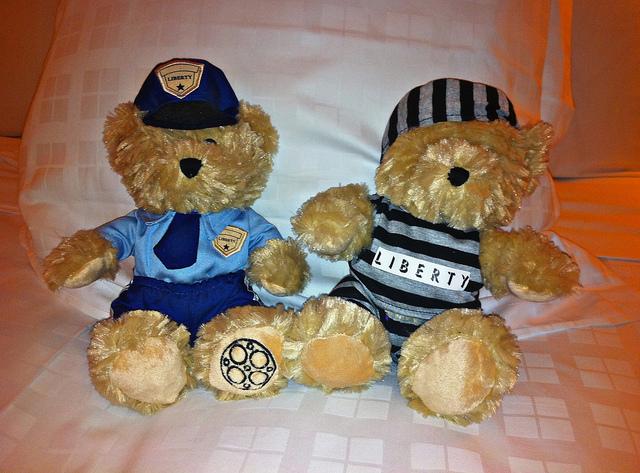What does the logo say?
Concise answer only. Liberty. How many eyes are in the picture?
Quick response, please. 1. What is the pattern on the bedspread?
Concise answer only. Checkered. Are the bears sitting on a sofa?
Quick response, please. No. How many circle's are on police bear's foot?
Answer briefly. 4. Which teddy bear has the words liberty on it?
Answer briefly. Right. IS the passed out bear wearing any blue?
Give a very brief answer. Yes. What would make you think the brown bear is male?
Give a very brief answer. Clothing. 